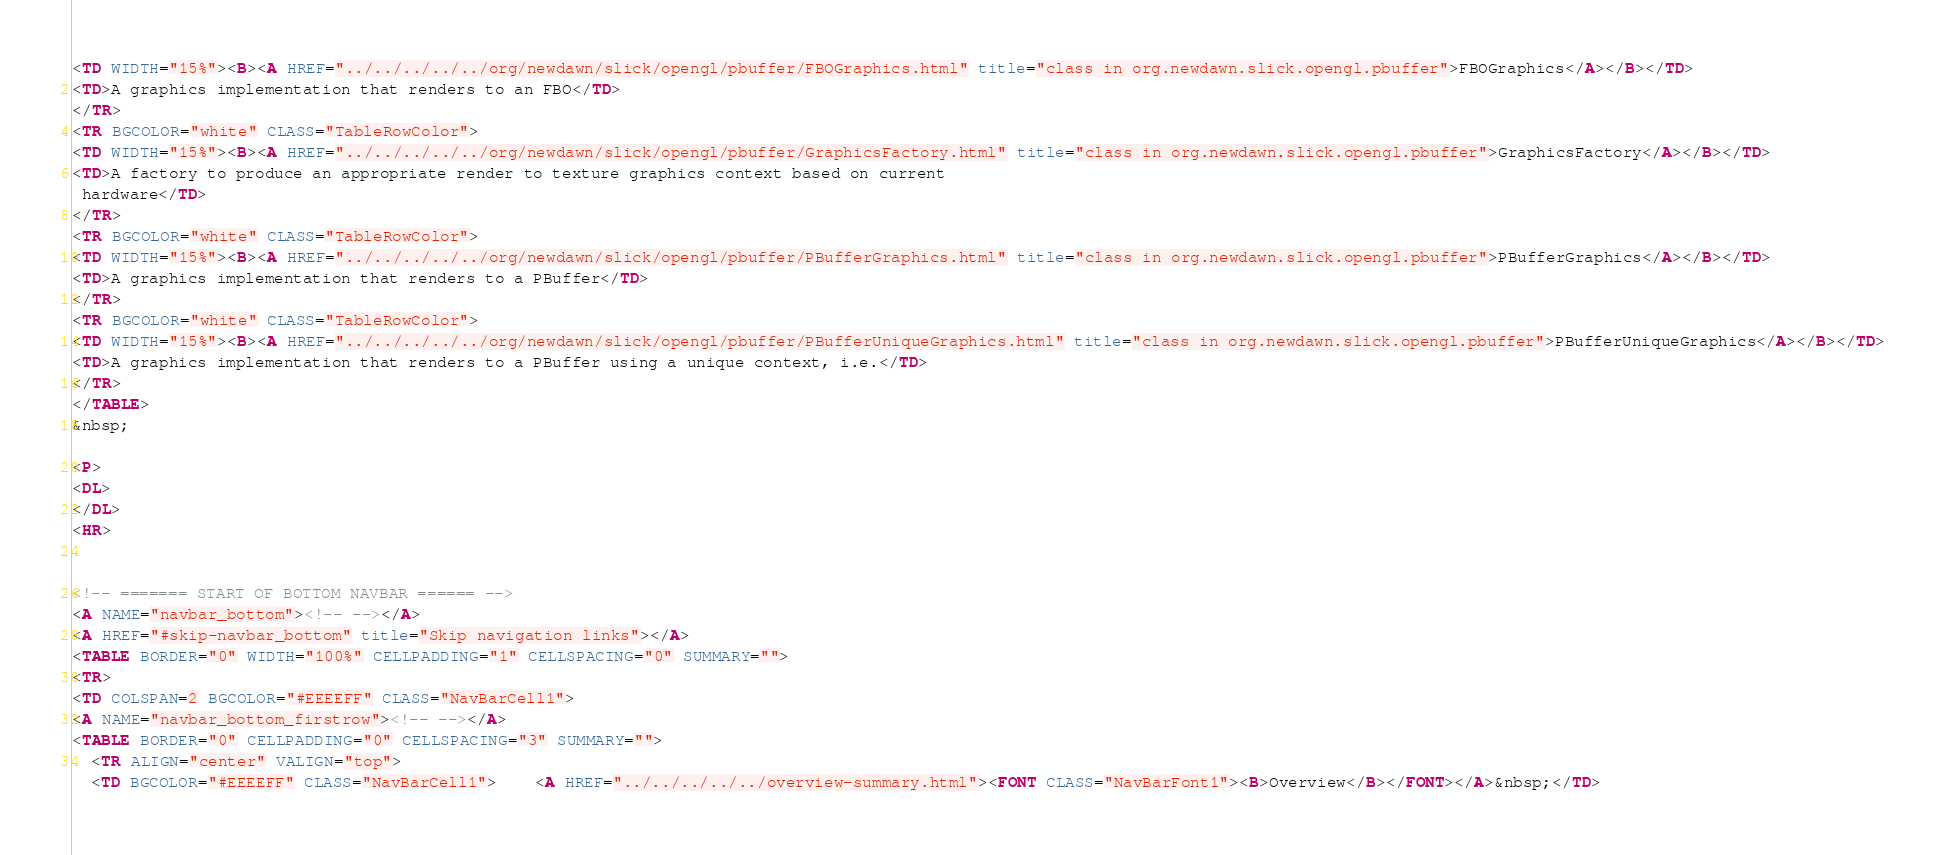<code> <loc_0><loc_0><loc_500><loc_500><_HTML_><TD WIDTH="15%"><B><A HREF="../../../../../org/newdawn/slick/opengl/pbuffer/FBOGraphics.html" title="class in org.newdawn.slick.opengl.pbuffer">FBOGraphics</A></B></TD>
<TD>A graphics implementation that renders to an FBO</TD>
</TR>
<TR BGCOLOR="white" CLASS="TableRowColor">
<TD WIDTH="15%"><B><A HREF="../../../../../org/newdawn/slick/opengl/pbuffer/GraphicsFactory.html" title="class in org.newdawn.slick.opengl.pbuffer">GraphicsFactory</A></B></TD>
<TD>A factory to produce an appropriate render to texture graphics context based on current
 hardware</TD>
</TR>
<TR BGCOLOR="white" CLASS="TableRowColor">
<TD WIDTH="15%"><B><A HREF="../../../../../org/newdawn/slick/opengl/pbuffer/PBufferGraphics.html" title="class in org.newdawn.slick.opengl.pbuffer">PBufferGraphics</A></B></TD>
<TD>A graphics implementation that renders to a PBuffer</TD>
</TR>
<TR BGCOLOR="white" CLASS="TableRowColor">
<TD WIDTH="15%"><B><A HREF="../../../../../org/newdawn/slick/opengl/pbuffer/PBufferUniqueGraphics.html" title="class in org.newdawn.slick.opengl.pbuffer">PBufferUniqueGraphics</A></B></TD>
<TD>A graphics implementation that renders to a PBuffer using a unique context, i.e.</TD>
</TR>
</TABLE>
&nbsp;

<P>
<DL>
</DL>
<HR>


<!-- ======= START OF BOTTOM NAVBAR ====== -->
<A NAME="navbar_bottom"><!-- --></A>
<A HREF="#skip-navbar_bottom" title="Skip navigation links"></A>
<TABLE BORDER="0" WIDTH="100%" CELLPADDING="1" CELLSPACING="0" SUMMARY="">
<TR>
<TD COLSPAN=2 BGCOLOR="#EEEEFF" CLASS="NavBarCell1">
<A NAME="navbar_bottom_firstrow"><!-- --></A>
<TABLE BORDER="0" CELLPADDING="0" CELLSPACING="3" SUMMARY="">
  <TR ALIGN="center" VALIGN="top">
  <TD BGCOLOR="#EEEEFF" CLASS="NavBarCell1">    <A HREF="../../../../../overview-summary.html"><FONT CLASS="NavBarFont1"><B>Overview</B></FONT></A>&nbsp;</TD></code> 